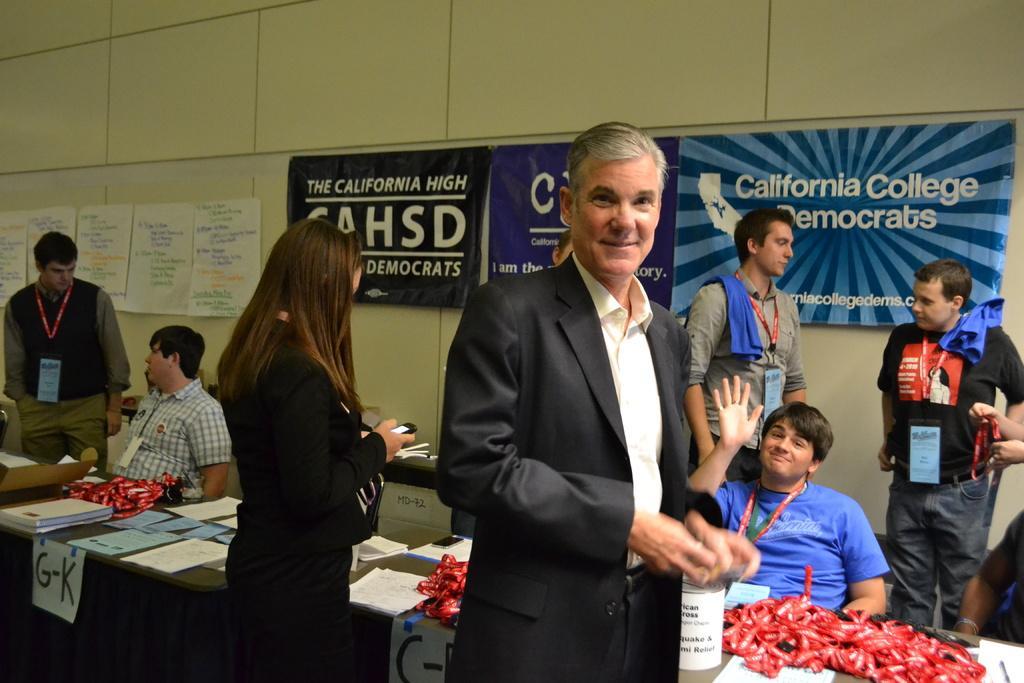Describe this image in one or two sentences. In this image I can see a person wearing white shirt, black blazer and black pant is standing and a woman wearing black dress is standing and holding a cellphone in her hand. In the background I can see two person sitting on chairs in front of a table on which I can see few papers and few red colored objects. I can see few persons standing, the cream colored wall, few papers attached to the wall and few banners to the wall. 